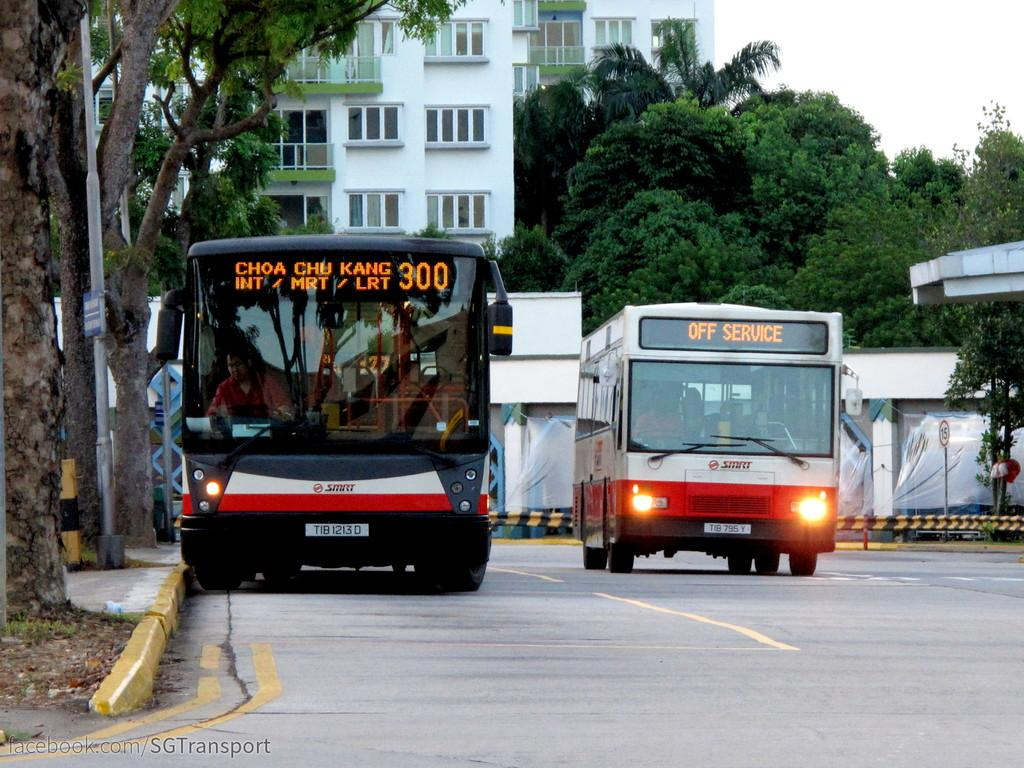How many vehicles are present in the image? There are two vehicles in the image. What are the vehicles doing? The vehicles are on the road. What can be seen in the background of the image? Buildings, windows, poles, trees, a sign board, and the sky are visible in the background. What type of pie is being served at the haircut salon in the image? There is no haircut salon or pie present in the image. How much dust is visible on the vehicles in the image? The image does not provide information about the amount of dust on the vehicles. 